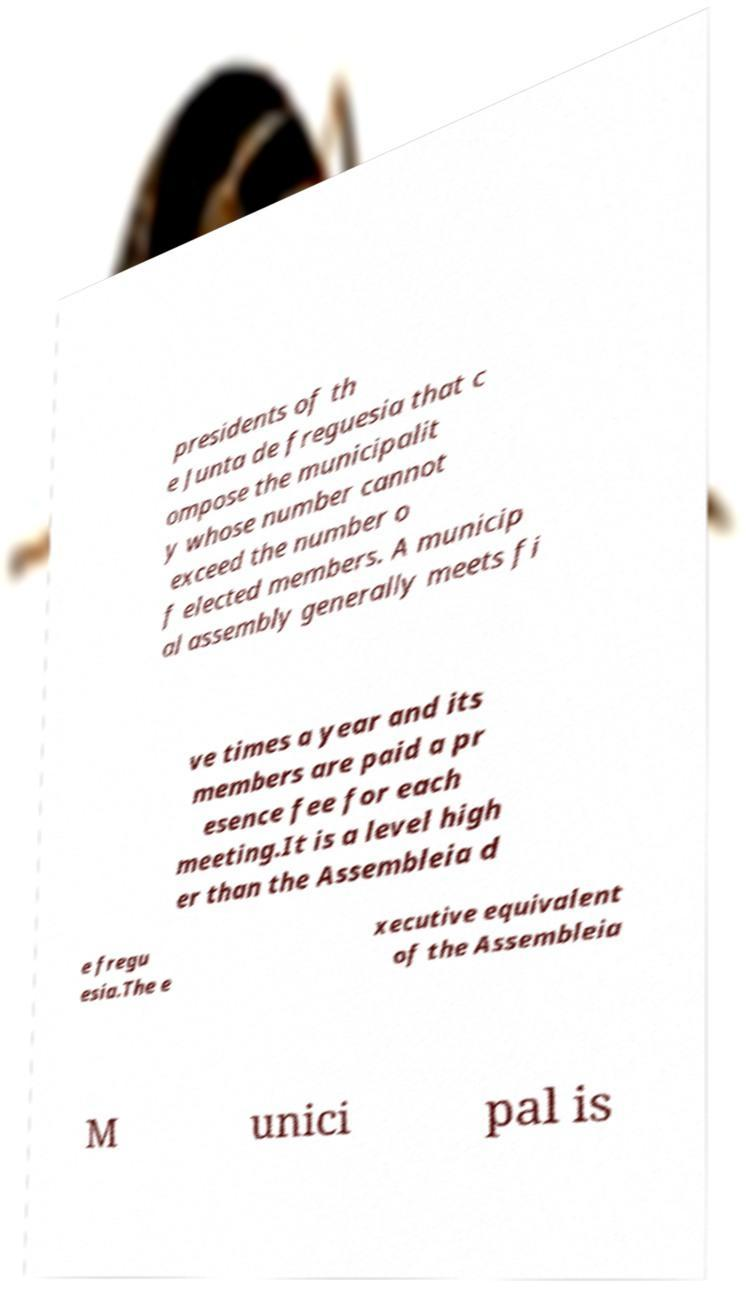I need the written content from this picture converted into text. Can you do that? presidents of th e Junta de freguesia that c ompose the municipalit y whose number cannot exceed the number o f elected members. A municip al assembly generally meets fi ve times a year and its members are paid a pr esence fee for each meeting.It is a level high er than the Assembleia d e fregu esia.The e xecutive equivalent of the Assembleia M unici pal is 